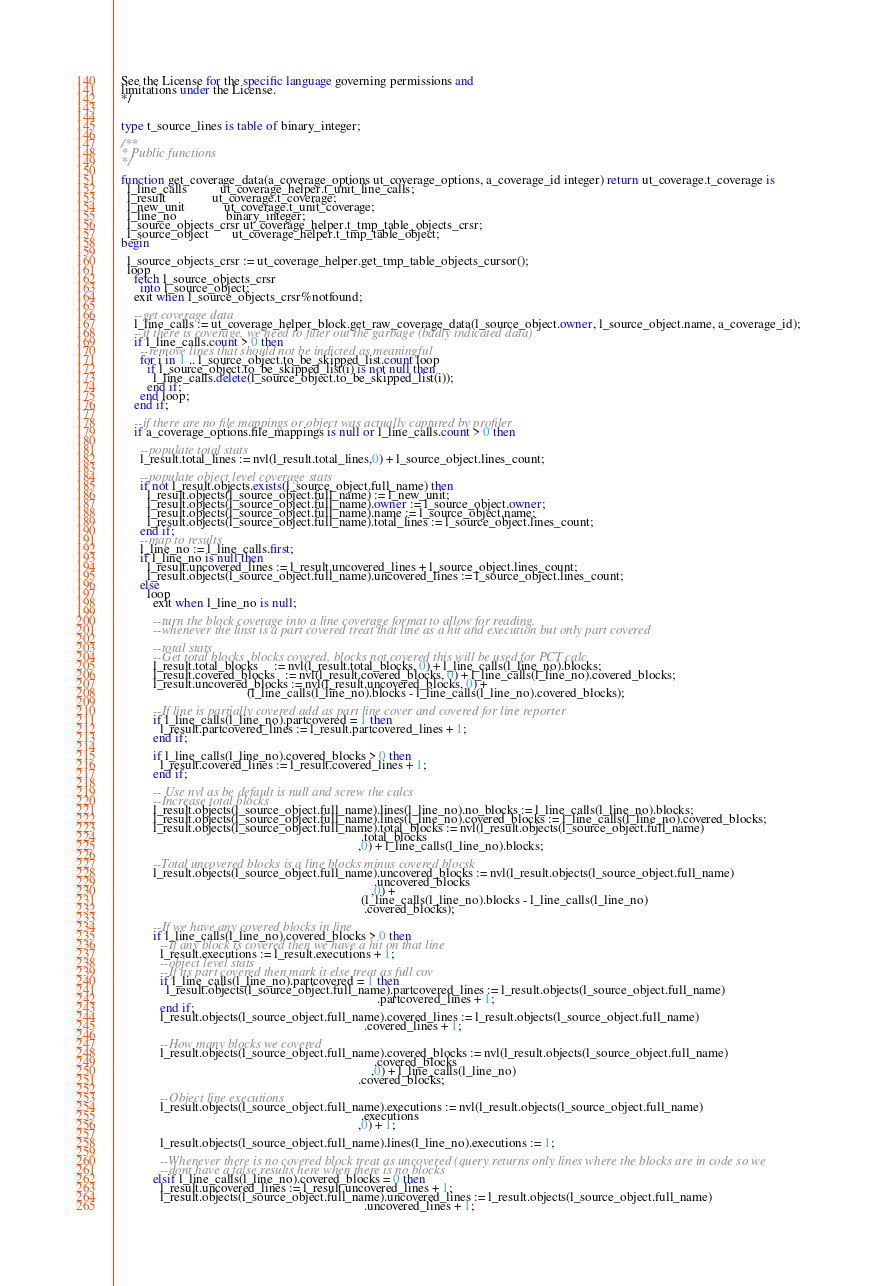<code> <loc_0><loc_0><loc_500><loc_500><_SQL_>  See the License for the specific language governing permissions and
  limitations under the License.
  */

  
  type t_source_lines is table of binary_integer;

  /**
  * Public functions
  */

  function get_coverage_data(a_coverage_options ut_coverage_options, a_coverage_id integer) return ut_coverage.t_coverage is
    l_line_calls          ut_coverage_helper.t_unit_line_calls;
    l_result              ut_coverage.t_coverage;
    l_new_unit            ut_coverage.t_unit_coverage;
    l_line_no               binary_integer;
    l_source_objects_crsr ut_coverage_helper.t_tmp_table_objects_crsr;
    l_source_object       ut_coverage_helper.t_tmp_table_object;
  begin

    l_source_objects_crsr := ut_coverage_helper.get_tmp_table_objects_cursor();
    loop
      fetch l_source_objects_crsr
        into l_source_object;
      exit when l_source_objects_crsr%notfound;
    
      --get coverage data
      l_line_calls := ut_coverage_helper_block.get_raw_coverage_data(l_source_object.owner, l_source_object.name, a_coverage_id);
      --if there is coverage, we need to filter out the garbage (badly indicated data)
      if l_line_calls.count > 0 then
        --remove lines that should not be indicted as meaningful
        for i in 1 .. l_source_object.to_be_skipped_list.count loop
          if l_source_object.to_be_skipped_list(i) is not null then
            l_line_calls.delete(l_source_object.to_be_skipped_list(i));
          end if;
        end loop;
      end if;
    
      --if there are no file mappings or object was actually captured by profiler
      if a_coverage_options.file_mappings is null or l_line_calls.count > 0 then
      
        --populate total stats
        l_result.total_lines := nvl(l_result.total_lines,0) + l_source_object.lines_count;
      
        --populate object level coverage stats
        if not l_result.objects.exists(l_source_object.full_name) then
          l_result.objects(l_source_object.full_name) := l_new_unit;
          l_result.objects(l_source_object.full_name).owner := l_source_object.owner;
          l_result.objects(l_source_object.full_name).name := l_source_object.name;
          l_result.objects(l_source_object.full_name).total_lines := l_source_object.lines_count;
        end if;
        --map to results
        l_line_no := l_line_calls.first;
        if l_line_no is null then
          l_result.uncovered_lines := l_result.uncovered_lines + l_source_object.lines_count;
          l_result.objects(l_source_object.full_name).uncovered_lines := l_source_object.lines_count;
        else
          loop
            exit when l_line_no is null;
          
            --turn the block coverage into a line coverage format to allow for reading.
            --whenever the linst is a part covered treat that line as a hit and execution but only part covered
          
            --total stats        
            --Get total blocks ,blocks covered, blocks not covered this will be used for PCT calc
            l_result.total_blocks     := nvl(l_result.total_blocks, 0) + l_line_calls(l_line_no).blocks;
            l_result.covered_blocks   := nvl(l_result.covered_blocks, 0) + l_line_calls(l_line_no).covered_blocks;
            l_result.uncovered_blocks := nvl(l_result.uncovered_blocks, 0) +
                                         (l_line_calls(l_line_no).blocks - l_line_calls(l_line_no).covered_blocks);
          
            --If line is partially covered add as part line cover and covered for line reporter
            if l_line_calls(l_line_no).partcovered = 1 then
              l_result.partcovered_lines := l_result.partcovered_lines + 1;
            end if;
          
            if l_line_calls(l_line_no).covered_blocks > 0 then
              l_result.covered_lines := l_result.covered_lines + 1;
            end if;
          
            -- Use nvl as be default is null and screw the calcs
            --Increase total blocks
            l_result.objects(l_source_object.full_name).lines(l_line_no).no_blocks := l_line_calls(l_line_no).blocks;
            l_result.objects(l_source_object.full_name).lines(l_line_no).covered_blocks := l_line_calls(l_line_no).covered_blocks;
            l_result.objects(l_source_object.full_name).total_blocks := nvl(l_result.objects(l_source_object.full_name)
                                                                            .total_blocks
                                                                           ,0) + l_line_calls(l_line_no).blocks;
          
            --Total uncovered blocks is a line blocks minus covered blocsk
            l_result.objects(l_source_object.full_name).uncovered_blocks := nvl(l_result.objects(l_source_object.full_name)
                                                                                .uncovered_blocks
                                                                               ,0) +
                                                                            (l_line_calls(l_line_no).blocks - l_line_calls(l_line_no)
                                                                             .covered_blocks);
          
            --If we have any covered blocks in line
            if l_line_calls(l_line_no).covered_blocks > 0 then            
              --If any block is covered then we have a hit on that line
              l_result.executions := l_result.executions + 1;
              --object level stats
              --If its part covered then mark it else treat as full cov
              if l_line_calls(l_line_no).partcovered = 1 then
                l_result.objects(l_source_object.full_name).partcovered_lines := l_result.objects(l_source_object.full_name)
                                                                                 .partcovered_lines + 1;
              end if;
              l_result.objects(l_source_object.full_name).covered_lines := l_result.objects(l_source_object.full_name)
                                                                             .covered_lines + 1;
                         
              --How many blocks we covered
              l_result.objects(l_source_object.full_name).covered_blocks := nvl(l_result.objects(l_source_object.full_name)
                                                                                .covered_blocks
                                                                               ,0) + l_line_calls(l_line_no)
                                                                           .covered_blocks;
            
              --Object line executions
              l_result.objects(l_source_object.full_name).executions := nvl(l_result.objects(l_source_object.full_name)
                                                                            .executions
                                                                           ,0) + 1;
            
              l_result.objects(l_source_object.full_name).lines(l_line_no).executions := 1;
            
              --Whenever there is no covered block treat as uncovered (query returns only lines where the blocks are in code so we
              --dont have a false results here when there is no blocks
            elsif l_line_calls(l_line_no).covered_blocks = 0 then
              l_result.uncovered_lines := l_result.uncovered_lines + 1;
              l_result.objects(l_source_object.full_name).uncovered_lines := l_result.objects(l_source_object.full_name)
                                                                             .uncovered_lines + 1;</code> 